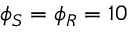Convert formula to latex. <formula><loc_0><loc_0><loc_500><loc_500>\phi _ { S } = \phi _ { R } = 1 0</formula> 